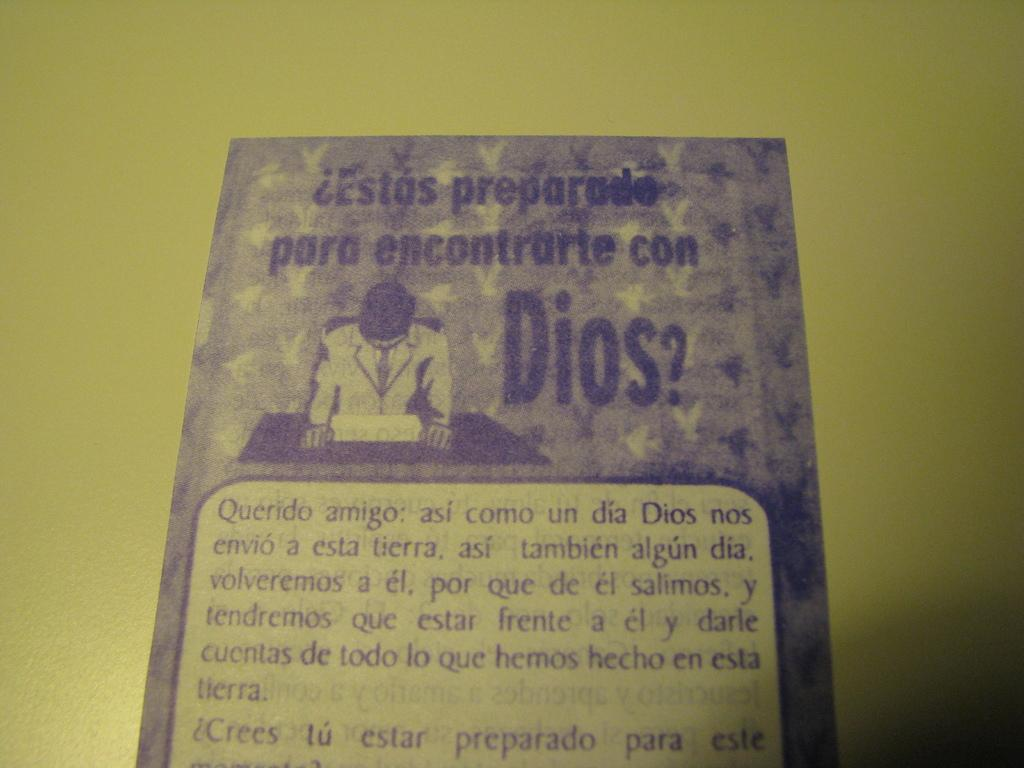<image>
Offer a succinct explanation of the picture presented. A card has the word dios on it in purple lettering. 